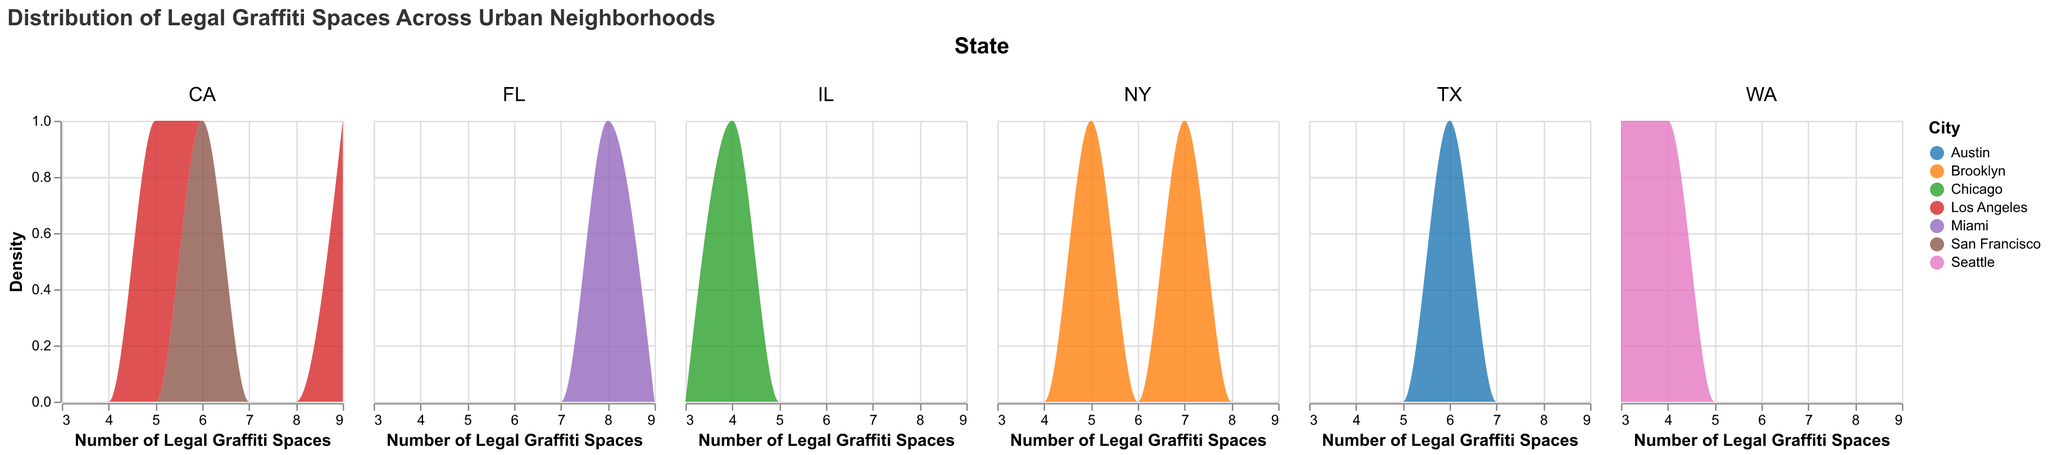What is the title of the figure? The title of the figure is shown at the top and reads "Distribution of Legal Graffiti Spaces Across Urban Neighborhoods".
Answer: Distribution of Legal Graffiti Spaces Across Urban Neighborhoods How many states are represented in the figure? There are five columns, each representing a different state. These states are NY, CA, FL, WA, IL, and TX.
Answer: 6 Which state has the neighborhood with the highest number of legal graffiti spaces? The Arts District in Los Angeles, CA has the highest number of legal graffiti spaces with 9.
Answer: CA Which neighborhood in Brooklyn, NY has more legal graffiti spaces? Bushwick has more legal graffiti spaces (7) compared to Williamsburg, which has 5.
Answer: Bushwick Which city has the highest overall number of legal graffiti spaces across its neighborhoods? Summing up the legal graffiti spaces for each city, Los Angeles (CA) has the highest total with Echo Park (5) and Arts District (9), totaling 14.
Answer: Los Angeles What is the total number of legal graffiti spaces in Seattle, WA? Fremont has 4 and Capitol Hill has 3 legal graffiti spaces. Summing these up results in 4 + 3 = 7.
Answer: 7 What is the average number of legal graffiti spaces across all neighborhoods shown? Adding up all the values: 5 (Williamsburg) + 7 (Bushwick) + 6 (Mission District) + 8 (Wynwood) + 4 (Fremont) + 4 (River North) + 5 (Echo Park) + 9 (Arts District) + 6 (East Austin) + 3 (Capitol Hill) = 57. There are 10 neighborhoods in total, so the average is 57 / 10 = 5.7.
Answer: 5.7 Which neighborhoods have the same number of legal graffiti spaces, and what is that number? Fremont, Seattle and River North, Chicago each have 4 legal graffiti spaces.
Answer: Fremont and River North, 4 What is the range of legal graffiti spaces across the neighborhoods shown in the figure? The neighborhood with the smallest number of legal graffiti spaces is Capitol Hill (3) and the largest is Arts District (9). The range is 9 - 3 = 6.
Answer: 6 Are neighborhoods in California more varied in number of legal graffiti spaces than those in Washington? California neighborhoods (Mission District: 6, Echo Park: 5, Arts District: 9) range from 5 to 9. Washington neighborhoods (Fremont: 4, Capitol Hill: 3) range from 3 to 4. Therefore, California's range of 4 (9 - 5) is greater than Washington's range of 1 (4 - 3).
Answer: Yes 